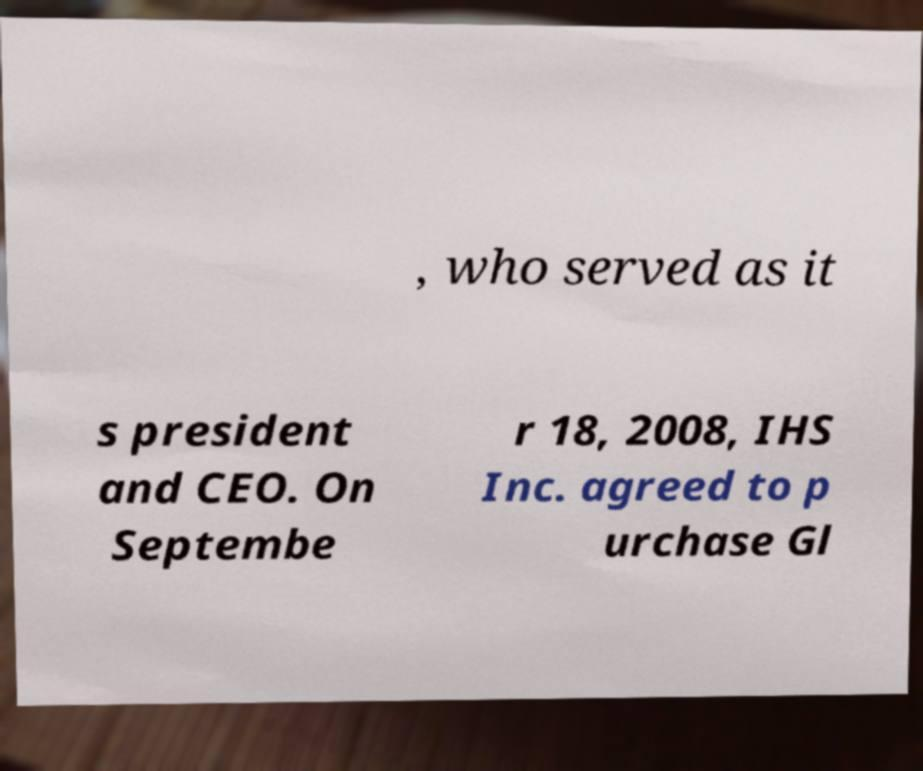Can you accurately transcribe the text from the provided image for me? , who served as it s president and CEO. On Septembe r 18, 2008, IHS Inc. agreed to p urchase Gl 